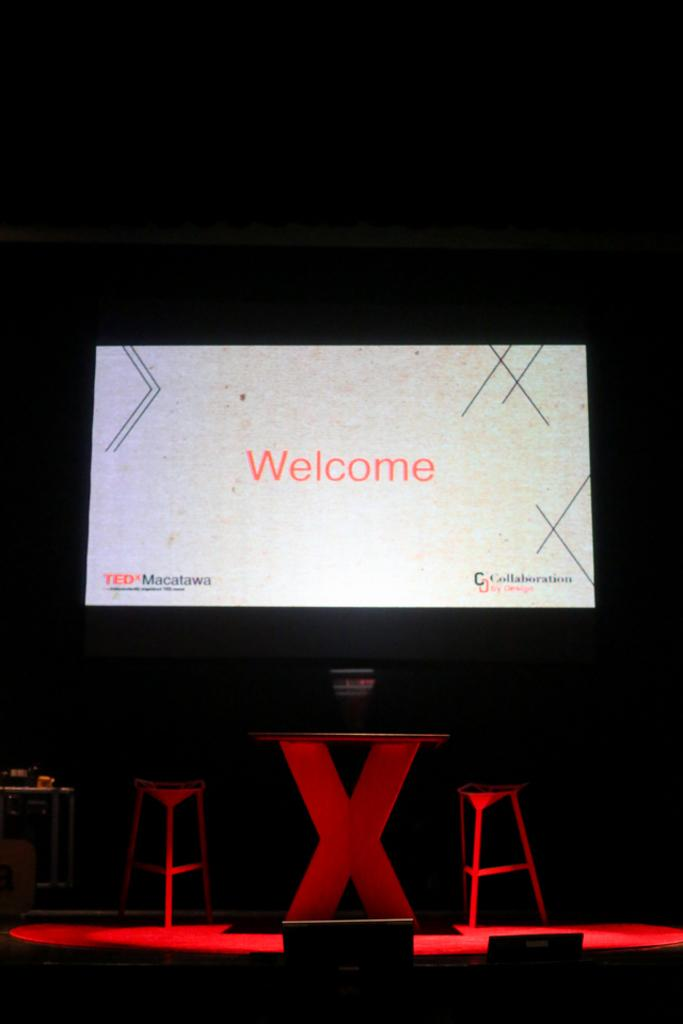Provide a one-sentence caption for the provided image. On a dark spotlit stage a large screen is welcoming those who see it. 